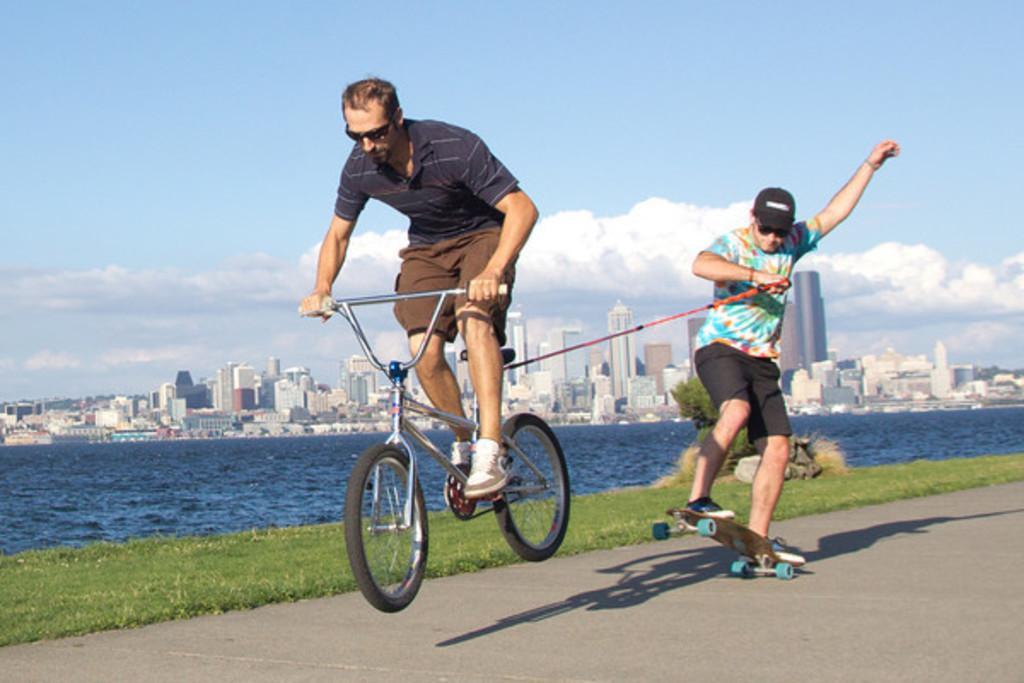In one or two sentences, can you explain what this image depicts? In this image there are two persons who are riding bicycle and skating on the road and at the background of the image there is water,building and sky. 